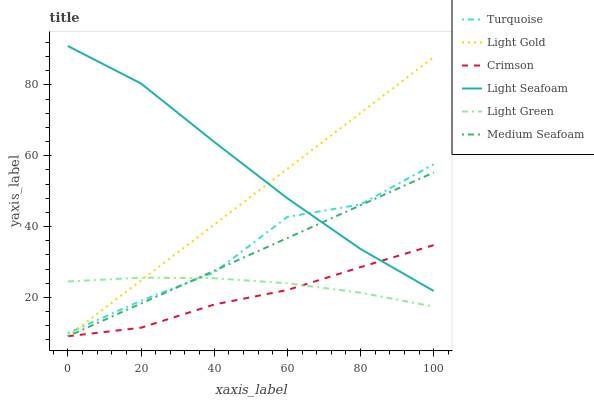Does Crimson have the minimum area under the curve?
Answer yes or no. Yes. Does Light Seafoam have the maximum area under the curve?
Answer yes or no. Yes. Does Light Green have the minimum area under the curve?
Answer yes or no. No. Does Light Green have the maximum area under the curve?
Answer yes or no. No. Is Medium Seafoam the smoothest?
Answer yes or no. Yes. Is Turquoise the roughest?
Answer yes or no. Yes. Is Light Green the smoothest?
Answer yes or no. No. Is Light Green the roughest?
Answer yes or no. No. Does Crimson have the lowest value?
Answer yes or no. Yes. Does Light Green have the lowest value?
Answer yes or no. No. Does Light Seafoam have the highest value?
Answer yes or no. Yes. Does Crimson have the highest value?
Answer yes or no. No. Is Crimson less than Turquoise?
Answer yes or no. Yes. Is Turquoise greater than Crimson?
Answer yes or no. Yes. Does Light Gold intersect Crimson?
Answer yes or no. Yes. Is Light Gold less than Crimson?
Answer yes or no. No. Is Light Gold greater than Crimson?
Answer yes or no. No. Does Crimson intersect Turquoise?
Answer yes or no. No. 